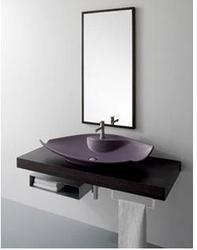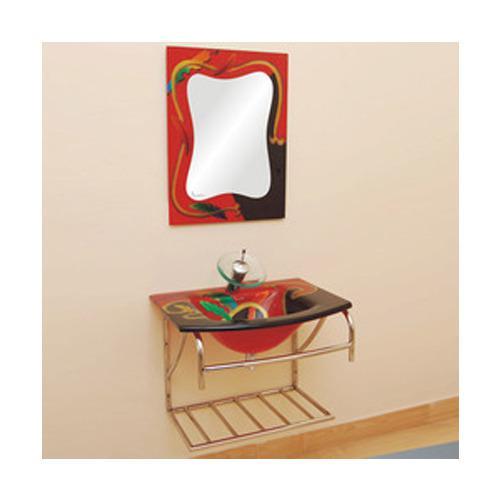The first image is the image on the left, the second image is the image on the right. Given the left and right images, does the statement "Neither picture contains a mirror that is shaped like a circle or an oval." hold true? Answer yes or no. Yes. 